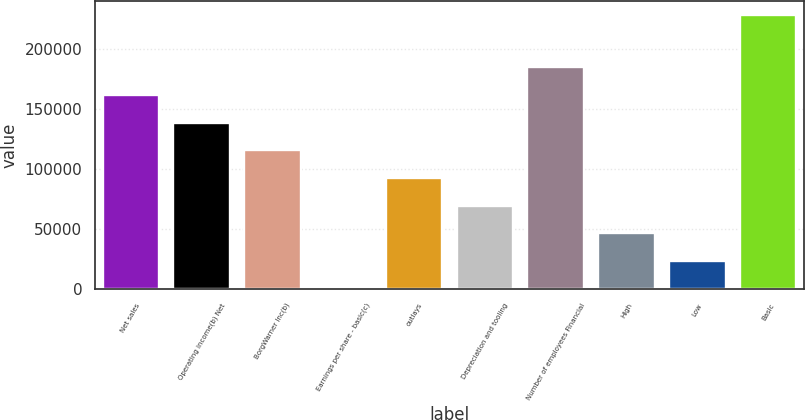<chart> <loc_0><loc_0><loc_500><loc_500><bar_chart><fcel>Net sales<fcel>Operating income(b) Net<fcel>BorgWarner Inc(b)<fcel>Earnings per share - basic(c)<fcel>outlays<fcel>Depreciation and tooling<fcel>Number of employees Financial<fcel>High<fcel>Low<fcel>Basic<nl><fcel>161937<fcel>138803<fcel>115670<fcel>2.73<fcel>92536.4<fcel>69403<fcel>185070<fcel>46269.6<fcel>23136.2<fcel>228600<nl></chart> 